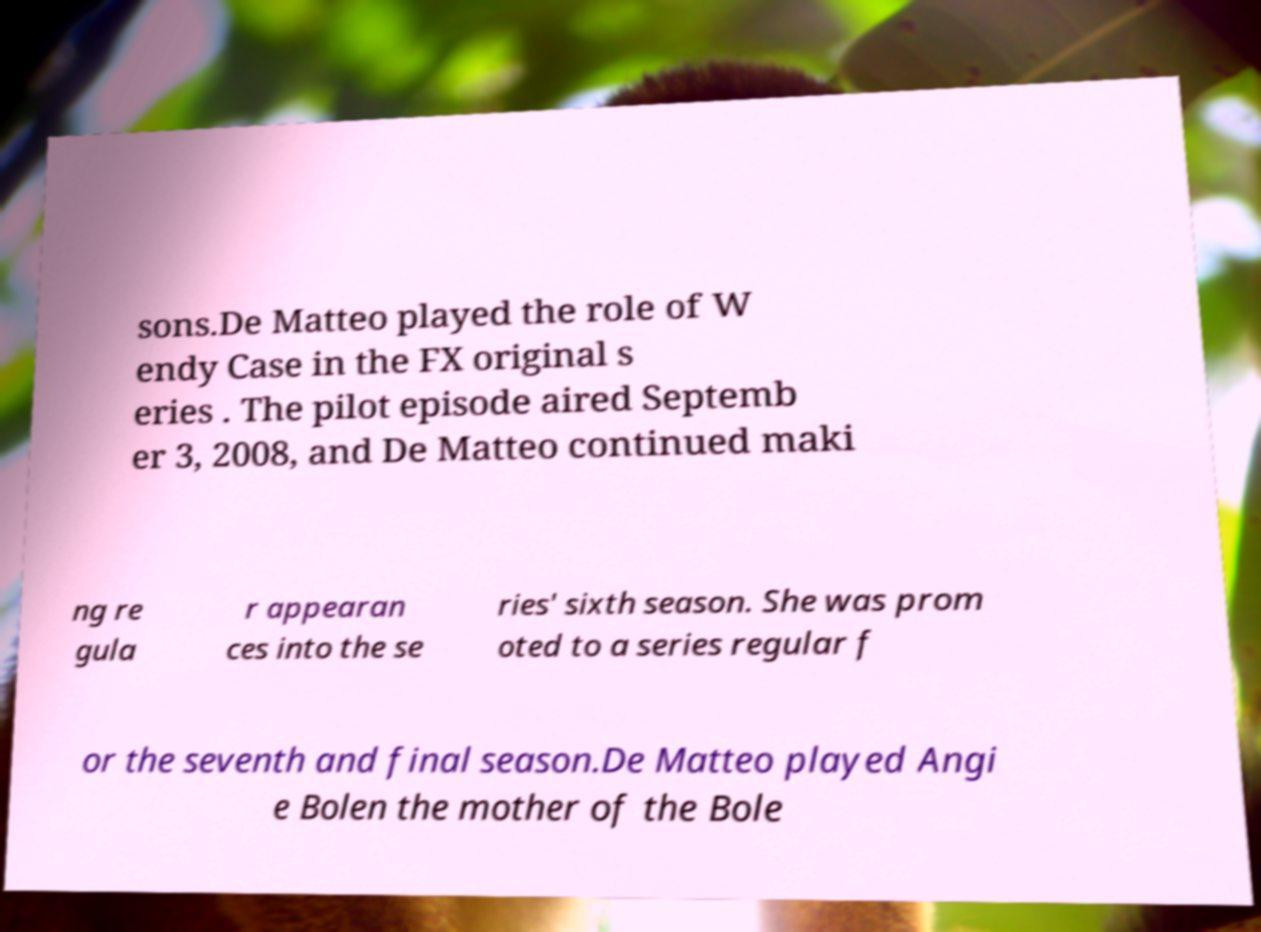Could you extract and type out the text from this image? sons.De Matteo played the role of W endy Case in the FX original s eries . The pilot episode aired Septemb er 3, 2008, and De Matteo continued maki ng re gula r appearan ces into the se ries' sixth season. She was prom oted to a series regular f or the seventh and final season.De Matteo played Angi e Bolen the mother of the Bole 